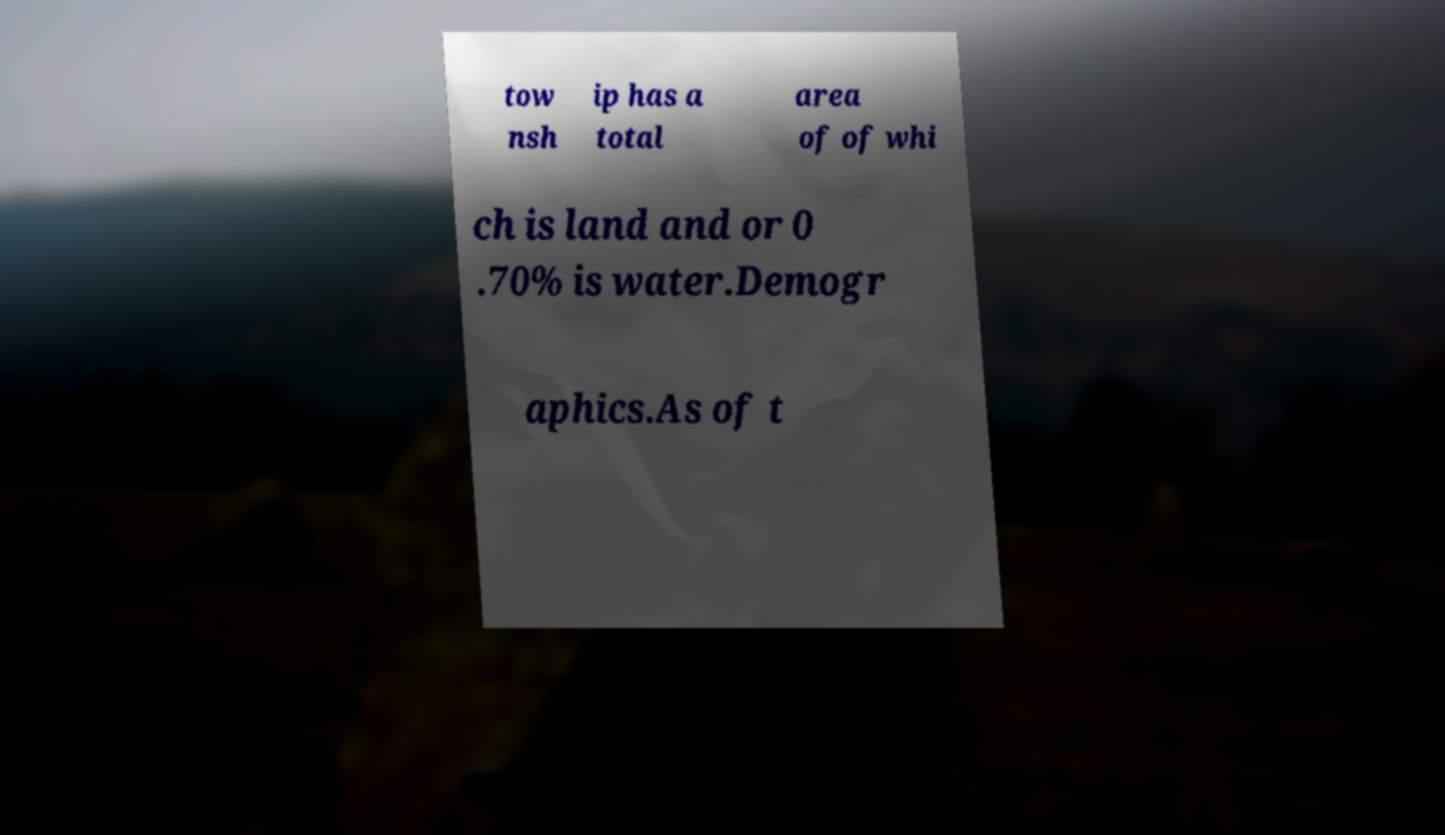Could you extract and type out the text from this image? tow nsh ip has a total area of of whi ch is land and or 0 .70% is water.Demogr aphics.As of t 